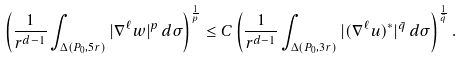<formula> <loc_0><loc_0><loc_500><loc_500>\left ( \frac { 1 } { r ^ { d - 1 } } \int _ { \Delta ( P _ { 0 } , 5 r ) } | \nabla ^ { \ell } w | ^ { p } \, d \sigma \right ) ^ { \frac { 1 } { p } } \leq C \left ( \frac { 1 } { r ^ { d - 1 } } \int _ { \Delta ( P _ { 0 } , 3 r ) } | ( \nabla ^ { \ell } u ) ^ { * } | ^ { \bar { q } } \, d \sigma \right ) ^ { \frac { 1 } { \bar { q } } } .</formula> 